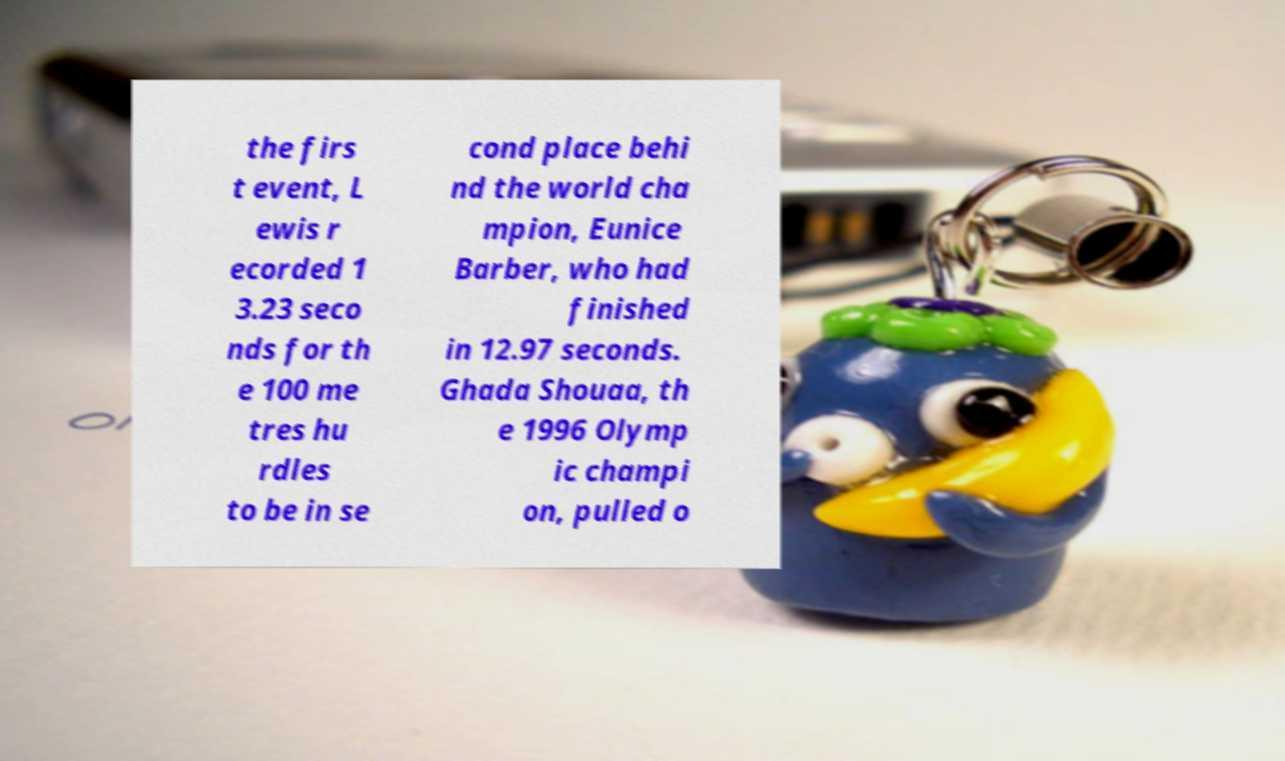Can you read and provide the text displayed in the image?This photo seems to have some interesting text. Can you extract and type it out for me? the firs t event, L ewis r ecorded 1 3.23 seco nds for th e 100 me tres hu rdles to be in se cond place behi nd the world cha mpion, Eunice Barber, who had finished in 12.97 seconds. Ghada Shouaa, th e 1996 Olymp ic champi on, pulled o 